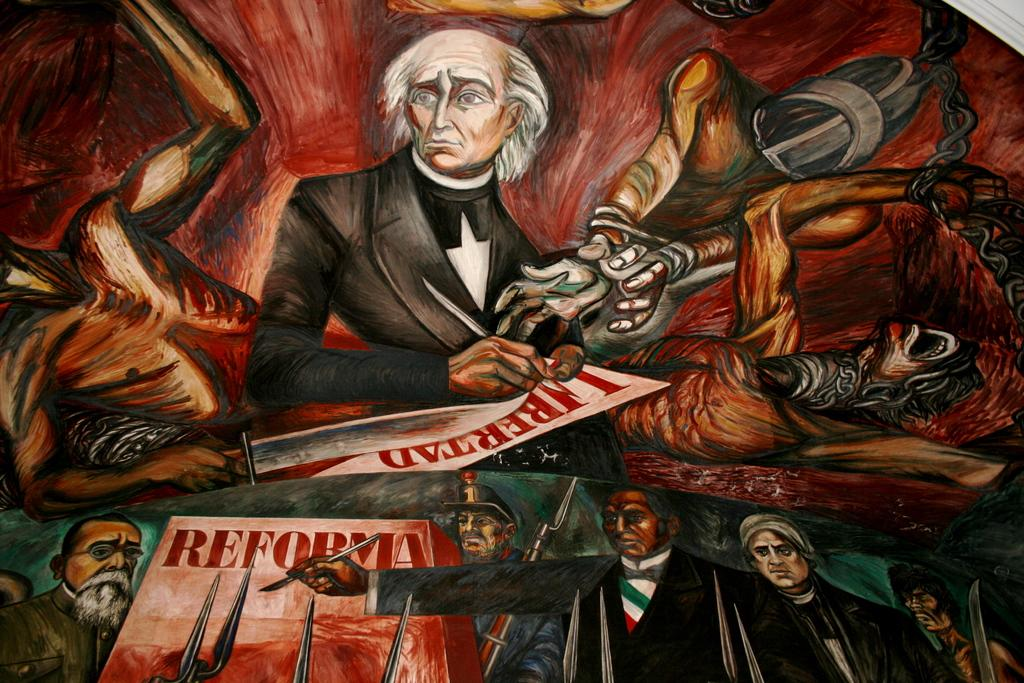<image>
Describe the image concisely. an artistic rendering of a man drawing posters with the word reforma in red letters. 